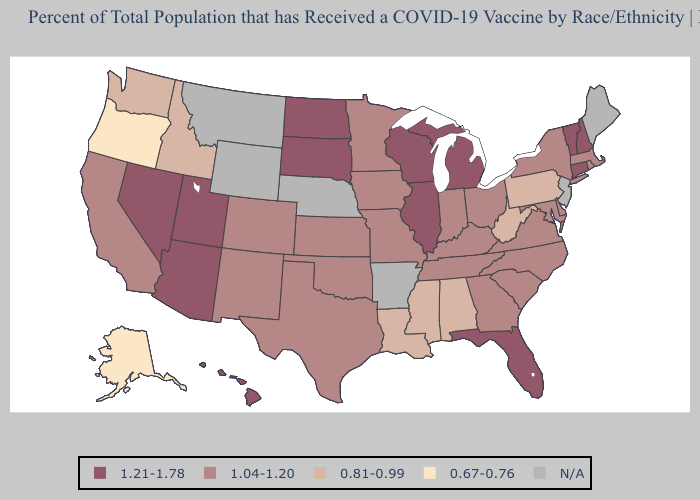How many symbols are there in the legend?
Quick response, please. 5. What is the lowest value in states that border Idaho?
Be succinct. 0.67-0.76. What is the lowest value in the USA?
Write a very short answer. 0.67-0.76. Among the states that border Washington , which have the lowest value?
Be succinct. Oregon. How many symbols are there in the legend?
Give a very brief answer. 5. Does Hawaii have the lowest value in the West?
Give a very brief answer. No. What is the highest value in states that border Tennessee?
Short answer required. 1.04-1.20. What is the highest value in the USA?
Concise answer only. 1.21-1.78. Name the states that have a value in the range 1.21-1.78?
Concise answer only. Arizona, Connecticut, Florida, Hawaii, Illinois, Michigan, Nevada, New Hampshire, North Dakota, South Dakota, Utah, Vermont, Wisconsin. What is the value of Florida?
Keep it brief. 1.21-1.78. What is the value of Louisiana?
Answer briefly. 0.81-0.99. Does the first symbol in the legend represent the smallest category?
Give a very brief answer. No. How many symbols are there in the legend?
Write a very short answer. 5. How many symbols are there in the legend?
Write a very short answer. 5. 